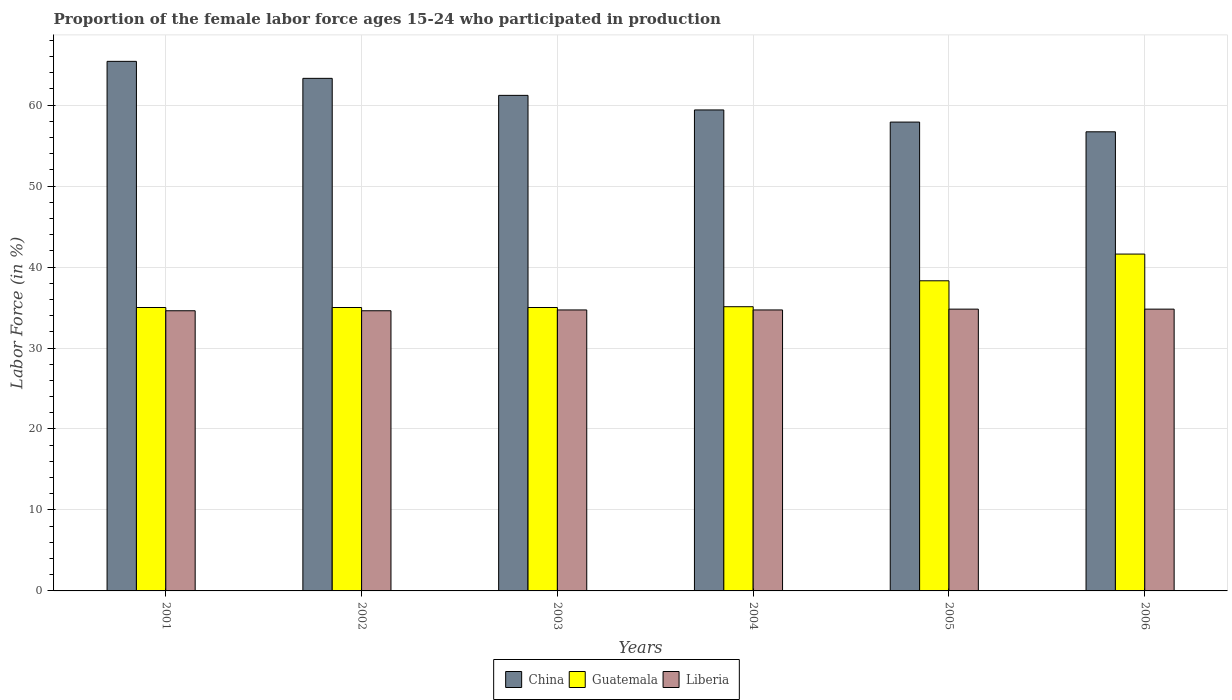How many groups of bars are there?
Make the answer very short. 6. How many bars are there on the 5th tick from the left?
Offer a terse response. 3. What is the label of the 5th group of bars from the left?
Your response must be concise. 2005. In how many cases, is the number of bars for a given year not equal to the number of legend labels?
Your answer should be compact. 0. What is the proportion of the female labor force who participated in production in Guatemala in 2006?
Offer a terse response. 41.6. Across all years, what is the maximum proportion of the female labor force who participated in production in Guatemala?
Offer a terse response. 41.6. Across all years, what is the minimum proportion of the female labor force who participated in production in China?
Your answer should be compact. 56.7. What is the total proportion of the female labor force who participated in production in Guatemala in the graph?
Give a very brief answer. 220. What is the difference between the proportion of the female labor force who participated in production in Guatemala in 2002 and that in 2005?
Keep it short and to the point. -3.3. What is the difference between the proportion of the female labor force who participated in production in Guatemala in 2001 and the proportion of the female labor force who participated in production in China in 2004?
Your answer should be very brief. -24.4. What is the average proportion of the female labor force who participated in production in Liberia per year?
Keep it short and to the point. 34.7. In the year 2005, what is the difference between the proportion of the female labor force who participated in production in Liberia and proportion of the female labor force who participated in production in China?
Offer a very short reply. -23.1. In how many years, is the proportion of the female labor force who participated in production in China greater than 18 %?
Offer a very short reply. 6. What is the ratio of the proportion of the female labor force who participated in production in Guatemala in 2003 to that in 2006?
Make the answer very short. 0.84. Is the difference between the proportion of the female labor force who participated in production in Liberia in 2005 and 2006 greater than the difference between the proportion of the female labor force who participated in production in China in 2005 and 2006?
Provide a short and direct response. No. What is the difference between the highest and the second highest proportion of the female labor force who participated in production in China?
Give a very brief answer. 2.1. What is the difference between the highest and the lowest proportion of the female labor force who participated in production in Guatemala?
Your response must be concise. 6.6. In how many years, is the proportion of the female labor force who participated in production in Liberia greater than the average proportion of the female labor force who participated in production in Liberia taken over all years?
Provide a short and direct response. 4. Is the sum of the proportion of the female labor force who participated in production in Guatemala in 2001 and 2003 greater than the maximum proportion of the female labor force who participated in production in Liberia across all years?
Give a very brief answer. Yes. What does the 1st bar from the left in 2006 represents?
Keep it short and to the point. China. What does the 1st bar from the right in 2002 represents?
Keep it short and to the point. Liberia. Is it the case that in every year, the sum of the proportion of the female labor force who participated in production in Liberia and proportion of the female labor force who participated in production in Guatemala is greater than the proportion of the female labor force who participated in production in China?
Provide a short and direct response. Yes. How many bars are there?
Offer a very short reply. 18. Are all the bars in the graph horizontal?
Offer a very short reply. No. How many years are there in the graph?
Your answer should be compact. 6. What is the difference between two consecutive major ticks on the Y-axis?
Give a very brief answer. 10. Are the values on the major ticks of Y-axis written in scientific E-notation?
Make the answer very short. No. Does the graph contain any zero values?
Offer a terse response. No. Where does the legend appear in the graph?
Your response must be concise. Bottom center. How many legend labels are there?
Ensure brevity in your answer.  3. What is the title of the graph?
Your answer should be very brief. Proportion of the female labor force ages 15-24 who participated in production. Does "Senegal" appear as one of the legend labels in the graph?
Offer a terse response. No. What is the label or title of the Y-axis?
Keep it short and to the point. Labor Force (in %). What is the Labor Force (in %) of China in 2001?
Your answer should be very brief. 65.4. What is the Labor Force (in %) in Guatemala in 2001?
Keep it short and to the point. 35. What is the Labor Force (in %) of Liberia in 2001?
Offer a terse response. 34.6. What is the Labor Force (in %) of China in 2002?
Provide a short and direct response. 63.3. What is the Labor Force (in %) of Liberia in 2002?
Your response must be concise. 34.6. What is the Labor Force (in %) in China in 2003?
Provide a short and direct response. 61.2. What is the Labor Force (in %) of Liberia in 2003?
Keep it short and to the point. 34.7. What is the Labor Force (in %) of China in 2004?
Offer a very short reply. 59.4. What is the Labor Force (in %) of Guatemala in 2004?
Provide a succinct answer. 35.1. What is the Labor Force (in %) in Liberia in 2004?
Provide a short and direct response. 34.7. What is the Labor Force (in %) in China in 2005?
Offer a terse response. 57.9. What is the Labor Force (in %) of Guatemala in 2005?
Keep it short and to the point. 38.3. What is the Labor Force (in %) of Liberia in 2005?
Make the answer very short. 34.8. What is the Labor Force (in %) in China in 2006?
Provide a short and direct response. 56.7. What is the Labor Force (in %) of Guatemala in 2006?
Ensure brevity in your answer.  41.6. What is the Labor Force (in %) in Liberia in 2006?
Your response must be concise. 34.8. Across all years, what is the maximum Labor Force (in %) of China?
Your response must be concise. 65.4. Across all years, what is the maximum Labor Force (in %) in Guatemala?
Offer a terse response. 41.6. Across all years, what is the maximum Labor Force (in %) of Liberia?
Provide a short and direct response. 34.8. Across all years, what is the minimum Labor Force (in %) in China?
Keep it short and to the point. 56.7. Across all years, what is the minimum Labor Force (in %) in Liberia?
Your response must be concise. 34.6. What is the total Labor Force (in %) in China in the graph?
Your response must be concise. 363.9. What is the total Labor Force (in %) of Guatemala in the graph?
Your response must be concise. 220. What is the total Labor Force (in %) of Liberia in the graph?
Your response must be concise. 208.2. What is the difference between the Labor Force (in %) of Guatemala in 2001 and that in 2002?
Offer a terse response. 0. What is the difference between the Labor Force (in %) in China in 2001 and that in 2003?
Make the answer very short. 4.2. What is the difference between the Labor Force (in %) in China in 2001 and that in 2004?
Provide a succinct answer. 6. What is the difference between the Labor Force (in %) in Guatemala in 2001 and that in 2004?
Your answer should be compact. -0.1. What is the difference between the Labor Force (in %) of Guatemala in 2001 and that in 2005?
Make the answer very short. -3.3. What is the difference between the Labor Force (in %) in Liberia in 2001 and that in 2005?
Provide a short and direct response. -0.2. What is the difference between the Labor Force (in %) of China in 2001 and that in 2006?
Your answer should be compact. 8.7. What is the difference between the Labor Force (in %) in Guatemala in 2001 and that in 2006?
Make the answer very short. -6.6. What is the difference between the Labor Force (in %) of China in 2002 and that in 2003?
Provide a short and direct response. 2.1. What is the difference between the Labor Force (in %) of Guatemala in 2002 and that in 2003?
Make the answer very short. 0. What is the difference between the Labor Force (in %) of Liberia in 2002 and that in 2003?
Your response must be concise. -0.1. What is the difference between the Labor Force (in %) of Guatemala in 2002 and that in 2004?
Offer a terse response. -0.1. What is the difference between the Labor Force (in %) of Liberia in 2002 and that in 2004?
Your response must be concise. -0.1. What is the difference between the Labor Force (in %) of China in 2002 and that in 2005?
Offer a terse response. 5.4. What is the difference between the Labor Force (in %) in Guatemala in 2002 and that in 2005?
Your response must be concise. -3.3. What is the difference between the Labor Force (in %) of Liberia in 2002 and that in 2005?
Your response must be concise. -0.2. What is the difference between the Labor Force (in %) in China in 2002 and that in 2006?
Provide a succinct answer. 6.6. What is the difference between the Labor Force (in %) in Guatemala in 2002 and that in 2006?
Your answer should be compact. -6.6. What is the difference between the Labor Force (in %) in Guatemala in 2003 and that in 2004?
Your response must be concise. -0.1. What is the difference between the Labor Force (in %) of Liberia in 2003 and that in 2004?
Your answer should be compact. 0. What is the difference between the Labor Force (in %) of China in 2003 and that in 2005?
Provide a succinct answer. 3.3. What is the difference between the Labor Force (in %) in Guatemala in 2003 and that in 2005?
Offer a terse response. -3.3. What is the difference between the Labor Force (in %) in Guatemala in 2003 and that in 2006?
Provide a succinct answer. -6.6. What is the difference between the Labor Force (in %) of Liberia in 2003 and that in 2006?
Offer a terse response. -0.1. What is the difference between the Labor Force (in %) of Guatemala in 2004 and that in 2005?
Provide a succinct answer. -3.2. What is the difference between the Labor Force (in %) in Liberia in 2004 and that in 2005?
Keep it short and to the point. -0.1. What is the difference between the Labor Force (in %) of China in 2004 and that in 2006?
Give a very brief answer. 2.7. What is the difference between the Labor Force (in %) of Guatemala in 2004 and that in 2006?
Provide a succinct answer. -6.5. What is the difference between the Labor Force (in %) of China in 2005 and that in 2006?
Offer a terse response. 1.2. What is the difference between the Labor Force (in %) in Guatemala in 2005 and that in 2006?
Ensure brevity in your answer.  -3.3. What is the difference between the Labor Force (in %) in China in 2001 and the Labor Force (in %) in Guatemala in 2002?
Offer a terse response. 30.4. What is the difference between the Labor Force (in %) of China in 2001 and the Labor Force (in %) of Liberia in 2002?
Your answer should be compact. 30.8. What is the difference between the Labor Force (in %) of China in 2001 and the Labor Force (in %) of Guatemala in 2003?
Keep it short and to the point. 30.4. What is the difference between the Labor Force (in %) in China in 2001 and the Labor Force (in %) in Liberia in 2003?
Offer a very short reply. 30.7. What is the difference between the Labor Force (in %) of Guatemala in 2001 and the Labor Force (in %) of Liberia in 2003?
Provide a succinct answer. 0.3. What is the difference between the Labor Force (in %) in China in 2001 and the Labor Force (in %) in Guatemala in 2004?
Provide a short and direct response. 30.3. What is the difference between the Labor Force (in %) of China in 2001 and the Labor Force (in %) of Liberia in 2004?
Give a very brief answer. 30.7. What is the difference between the Labor Force (in %) of China in 2001 and the Labor Force (in %) of Guatemala in 2005?
Ensure brevity in your answer.  27.1. What is the difference between the Labor Force (in %) in China in 2001 and the Labor Force (in %) in Liberia in 2005?
Your answer should be compact. 30.6. What is the difference between the Labor Force (in %) of China in 2001 and the Labor Force (in %) of Guatemala in 2006?
Offer a very short reply. 23.8. What is the difference between the Labor Force (in %) of China in 2001 and the Labor Force (in %) of Liberia in 2006?
Offer a very short reply. 30.6. What is the difference between the Labor Force (in %) in China in 2002 and the Labor Force (in %) in Guatemala in 2003?
Offer a terse response. 28.3. What is the difference between the Labor Force (in %) in China in 2002 and the Labor Force (in %) in Liberia in 2003?
Your response must be concise. 28.6. What is the difference between the Labor Force (in %) in China in 2002 and the Labor Force (in %) in Guatemala in 2004?
Give a very brief answer. 28.2. What is the difference between the Labor Force (in %) in China in 2002 and the Labor Force (in %) in Liberia in 2004?
Provide a short and direct response. 28.6. What is the difference between the Labor Force (in %) of China in 2002 and the Labor Force (in %) of Guatemala in 2006?
Offer a terse response. 21.7. What is the difference between the Labor Force (in %) in China in 2002 and the Labor Force (in %) in Liberia in 2006?
Make the answer very short. 28.5. What is the difference between the Labor Force (in %) of Guatemala in 2002 and the Labor Force (in %) of Liberia in 2006?
Provide a succinct answer. 0.2. What is the difference between the Labor Force (in %) of China in 2003 and the Labor Force (in %) of Guatemala in 2004?
Your answer should be compact. 26.1. What is the difference between the Labor Force (in %) of China in 2003 and the Labor Force (in %) of Liberia in 2004?
Provide a short and direct response. 26.5. What is the difference between the Labor Force (in %) of Guatemala in 2003 and the Labor Force (in %) of Liberia in 2004?
Make the answer very short. 0.3. What is the difference between the Labor Force (in %) in China in 2003 and the Labor Force (in %) in Guatemala in 2005?
Your response must be concise. 22.9. What is the difference between the Labor Force (in %) in China in 2003 and the Labor Force (in %) in Liberia in 2005?
Ensure brevity in your answer.  26.4. What is the difference between the Labor Force (in %) of China in 2003 and the Labor Force (in %) of Guatemala in 2006?
Your answer should be compact. 19.6. What is the difference between the Labor Force (in %) of China in 2003 and the Labor Force (in %) of Liberia in 2006?
Your response must be concise. 26.4. What is the difference between the Labor Force (in %) of Guatemala in 2003 and the Labor Force (in %) of Liberia in 2006?
Offer a very short reply. 0.2. What is the difference between the Labor Force (in %) in China in 2004 and the Labor Force (in %) in Guatemala in 2005?
Your answer should be compact. 21.1. What is the difference between the Labor Force (in %) in China in 2004 and the Labor Force (in %) in Liberia in 2005?
Your response must be concise. 24.6. What is the difference between the Labor Force (in %) in China in 2004 and the Labor Force (in %) in Guatemala in 2006?
Ensure brevity in your answer.  17.8. What is the difference between the Labor Force (in %) of China in 2004 and the Labor Force (in %) of Liberia in 2006?
Offer a terse response. 24.6. What is the difference between the Labor Force (in %) of Guatemala in 2004 and the Labor Force (in %) of Liberia in 2006?
Offer a terse response. 0.3. What is the difference between the Labor Force (in %) in China in 2005 and the Labor Force (in %) in Guatemala in 2006?
Provide a succinct answer. 16.3. What is the difference between the Labor Force (in %) in China in 2005 and the Labor Force (in %) in Liberia in 2006?
Give a very brief answer. 23.1. What is the difference between the Labor Force (in %) in Guatemala in 2005 and the Labor Force (in %) in Liberia in 2006?
Your answer should be compact. 3.5. What is the average Labor Force (in %) in China per year?
Make the answer very short. 60.65. What is the average Labor Force (in %) of Guatemala per year?
Provide a succinct answer. 36.67. What is the average Labor Force (in %) of Liberia per year?
Your answer should be very brief. 34.7. In the year 2001, what is the difference between the Labor Force (in %) in China and Labor Force (in %) in Guatemala?
Give a very brief answer. 30.4. In the year 2001, what is the difference between the Labor Force (in %) of China and Labor Force (in %) of Liberia?
Your answer should be compact. 30.8. In the year 2002, what is the difference between the Labor Force (in %) in China and Labor Force (in %) in Guatemala?
Keep it short and to the point. 28.3. In the year 2002, what is the difference between the Labor Force (in %) in China and Labor Force (in %) in Liberia?
Your answer should be compact. 28.7. In the year 2003, what is the difference between the Labor Force (in %) in China and Labor Force (in %) in Guatemala?
Give a very brief answer. 26.2. In the year 2004, what is the difference between the Labor Force (in %) in China and Labor Force (in %) in Guatemala?
Offer a terse response. 24.3. In the year 2004, what is the difference between the Labor Force (in %) in China and Labor Force (in %) in Liberia?
Your answer should be very brief. 24.7. In the year 2005, what is the difference between the Labor Force (in %) in China and Labor Force (in %) in Guatemala?
Offer a very short reply. 19.6. In the year 2005, what is the difference between the Labor Force (in %) in China and Labor Force (in %) in Liberia?
Your response must be concise. 23.1. In the year 2005, what is the difference between the Labor Force (in %) of Guatemala and Labor Force (in %) of Liberia?
Provide a short and direct response. 3.5. In the year 2006, what is the difference between the Labor Force (in %) in China and Labor Force (in %) in Guatemala?
Make the answer very short. 15.1. In the year 2006, what is the difference between the Labor Force (in %) in China and Labor Force (in %) in Liberia?
Your response must be concise. 21.9. In the year 2006, what is the difference between the Labor Force (in %) of Guatemala and Labor Force (in %) of Liberia?
Keep it short and to the point. 6.8. What is the ratio of the Labor Force (in %) of China in 2001 to that in 2002?
Your answer should be very brief. 1.03. What is the ratio of the Labor Force (in %) of Guatemala in 2001 to that in 2002?
Ensure brevity in your answer.  1. What is the ratio of the Labor Force (in %) of Liberia in 2001 to that in 2002?
Offer a terse response. 1. What is the ratio of the Labor Force (in %) of China in 2001 to that in 2003?
Keep it short and to the point. 1.07. What is the ratio of the Labor Force (in %) in China in 2001 to that in 2004?
Provide a short and direct response. 1.1. What is the ratio of the Labor Force (in %) of China in 2001 to that in 2005?
Your answer should be very brief. 1.13. What is the ratio of the Labor Force (in %) in Guatemala in 2001 to that in 2005?
Provide a short and direct response. 0.91. What is the ratio of the Labor Force (in %) in Liberia in 2001 to that in 2005?
Give a very brief answer. 0.99. What is the ratio of the Labor Force (in %) of China in 2001 to that in 2006?
Your answer should be compact. 1.15. What is the ratio of the Labor Force (in %) in Guatemala in 2001 to that in 2006?
Your response must be concise. 0.84. What is the ratio of the Labor Force (in %) of Liberia in 2001 to that in 2006?
Your response must be concise. 0.99. What is the ratio of the Labor Force (in %) in China in 2002 to that in 2003?
Provide a short and direct response. 1.03. What is the ratio of the Labor Force (in %) in Guatemala in 2002 to that in 2003?
Your response must be concise. 1. What is the ratio of the Labor Force (in %) in Liberia in 2002 to that in 2003?
Make the answer very short. 1. What is the ratio of the Labor Force (in %) of China in 2002 to that in 2004?
Ensure brevity in your answer.  1.07. What is the ratio of the Labor Force (in %) of Liberia in 2002 to that in 2004?
Offer a terse response. 1. What is the ratio of the Labor Force (in %) in China in 2002 to that in 2005?
Make the answer very short. 1.09. What is the ratio of the Labor Force (in %) of Guatemala in 2002 to that in 2005?
Your answer should be very brief. 0.91. What is the ratio of the Labor Force (in %) in China in 2002 to that in 2006?
Give a very brief answer. 1.12. What is the ratio of the Labor Force (in %) of Guatemala in 2002 to that in 2006?
Keep it short and to the point. 0.84. What is the ratio of the Labor Force (in %) in China in 2003 to that in 2004?
Keep it short and to the point. 1.03. What is the ratio of the Labor Force (in %) of Liberia in 2003 to that in 2004?
Offer a very short reply. 1. What is the ratio of the Labor Force (in %) in China in 2003 to that in 2005?
Provide a succinct answer. 1.06. What is the ratio of the Labor Force (in %) in Guatemala in 2003 to that in 2005?
Offer a very short reply. 0.91. What is the ratio of the Labor Force (in %) in China in 2003 to that in 2006?
Your response must be concise. 1.08. What is the ratio of the Labor Force (in %) in Guatemala in 2003 to that in 2006?
Give a very brief answer. 0.84. What is the ratio of the Labor Force (in %) in China in 2004 to that in 2005?
Give a very brief answer. 1.03. What is the ratio of the Labor Force (in %) in Guatemala in 2004 to that in 2005?
Provide a short and direct response. 0.92. What is the ratio of the Labor Force (in %) of China in 2004 to that in 2006?
Offer a very short reply. 1.05. What is the ratio of the Labor Force (in %) in Guatemala in 2004 to that in 2006?
Keep it short and to the point. 0.84. What is the ratio of the Labor Force (in %) of China in 2005 to that in 2006?
Offer a terse response. 1.02. What is the ratio of the Labor Force (in %) of Guatemala in 2005 to that in 2006?
Give a very brief answer. 0.92. What is the ratio of the Labor Force (in %) in Liberia in 2005 to that in 2006?
Give a very brief answer. 1. What is the difference between the highest and the second highest Labor Force (in %) of Guatemala?
Offer a very short reply. 3.3. What is the difference between the highest and the second highest Labor Force (in %) in Liberia?
Your answer should be very brief. 0. What is the difference between the highest and the lowest Labor Force (in %) in Guatemala?
Ensure brevity in your answer.  6.6. What is the difference between the highest and the lowest Labor Force (in %) of Liberia?
Keep it short and to the point. 0.2. 